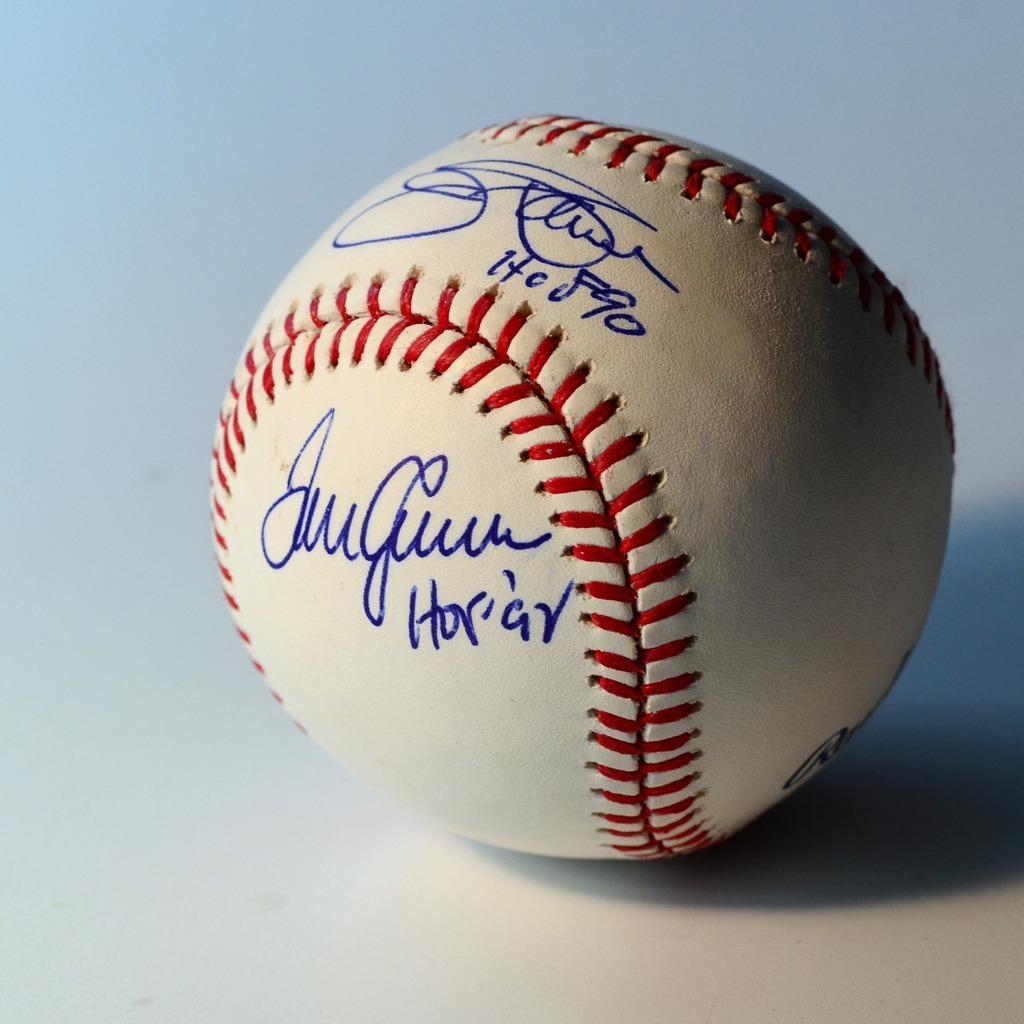Please provide a concise description of this image. In the center of the image we can see a ball is present on the surface. On the ball we can see the text. 